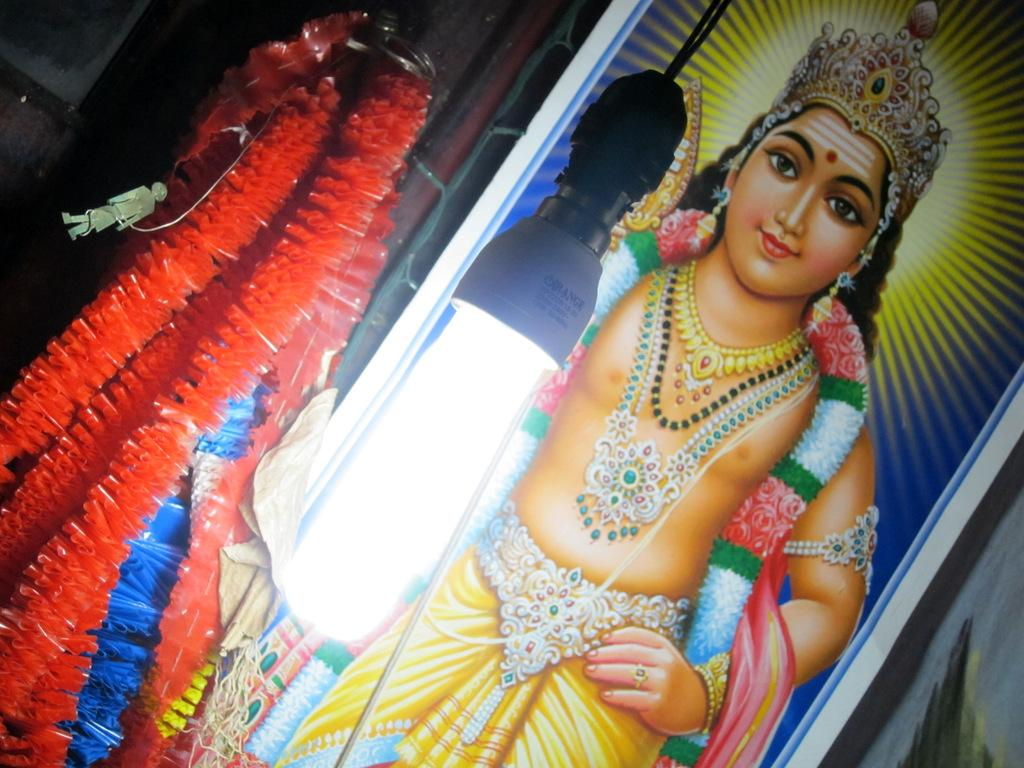What is located in the foreground of the image? There is a light in the foreground of the image. What type of decorations can be seen on the left side of the image? There are artificial garlands on the left side of the image. What is featured on the right side of the image? There is a frame of an idol on the right side of the image. What type of beast can be seen pulling a bun on the trains in the image? There are no beasts, buns, or trains present in the image. How many buns are being pulled by the beast on the trains in the image? There are no buns or trains present in the image, so it is impossible to determine how many buns are being pulled. 